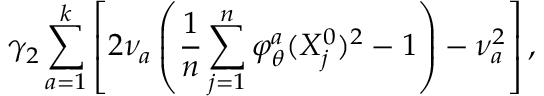<formula> <loc_0><loc_0><loc_500><loc_500>\gamma _ { 2 } \sum _ { a = 1 } ^ { k } \left [ 2 \nu _ { a } \left ( \frac { 1 } { n } \sum _ { j = 1 } ^ { n } \varphi _ { \theta } ^ { a } ( X _ { j } ^ { 0 } ) ^ { 2 } - 1 \right ) - \nu _ { a } ^ { 2 } \right ] ,</formula> 